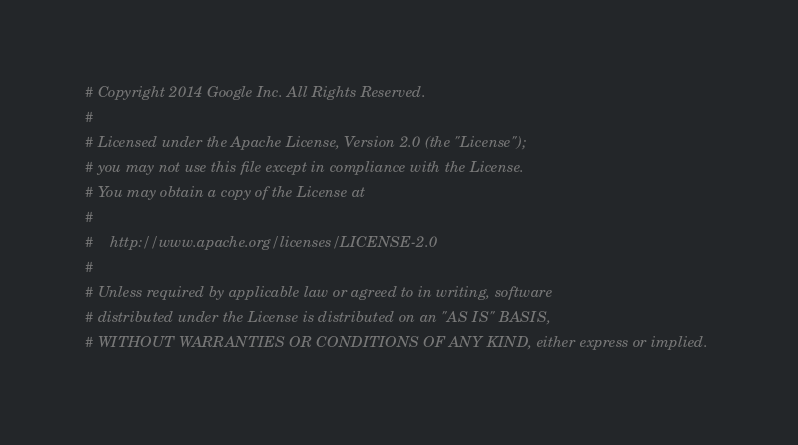Convert code to text. <code><loc_0><loc_0><loc_500><loc_500><_Python_># Copyright 2014 Google Inc. All Rights Reserved.
#
# Licensed under the Apache License, Version 2.0 (the "License");
# you may not use this file except in compliance with the License.
# You may obtain a copy of the License at
#
#    http://www.apache.org/licenses/LICENSE-2.0
#
# Unless required by applicable law or agreed to in writing, software
# distributed under the License is distributed on an "AS IS" BASIS,
# WITHOUT WARRANTIES OR CONDITIONS OF ANY KIND, either express or implied.</code> 